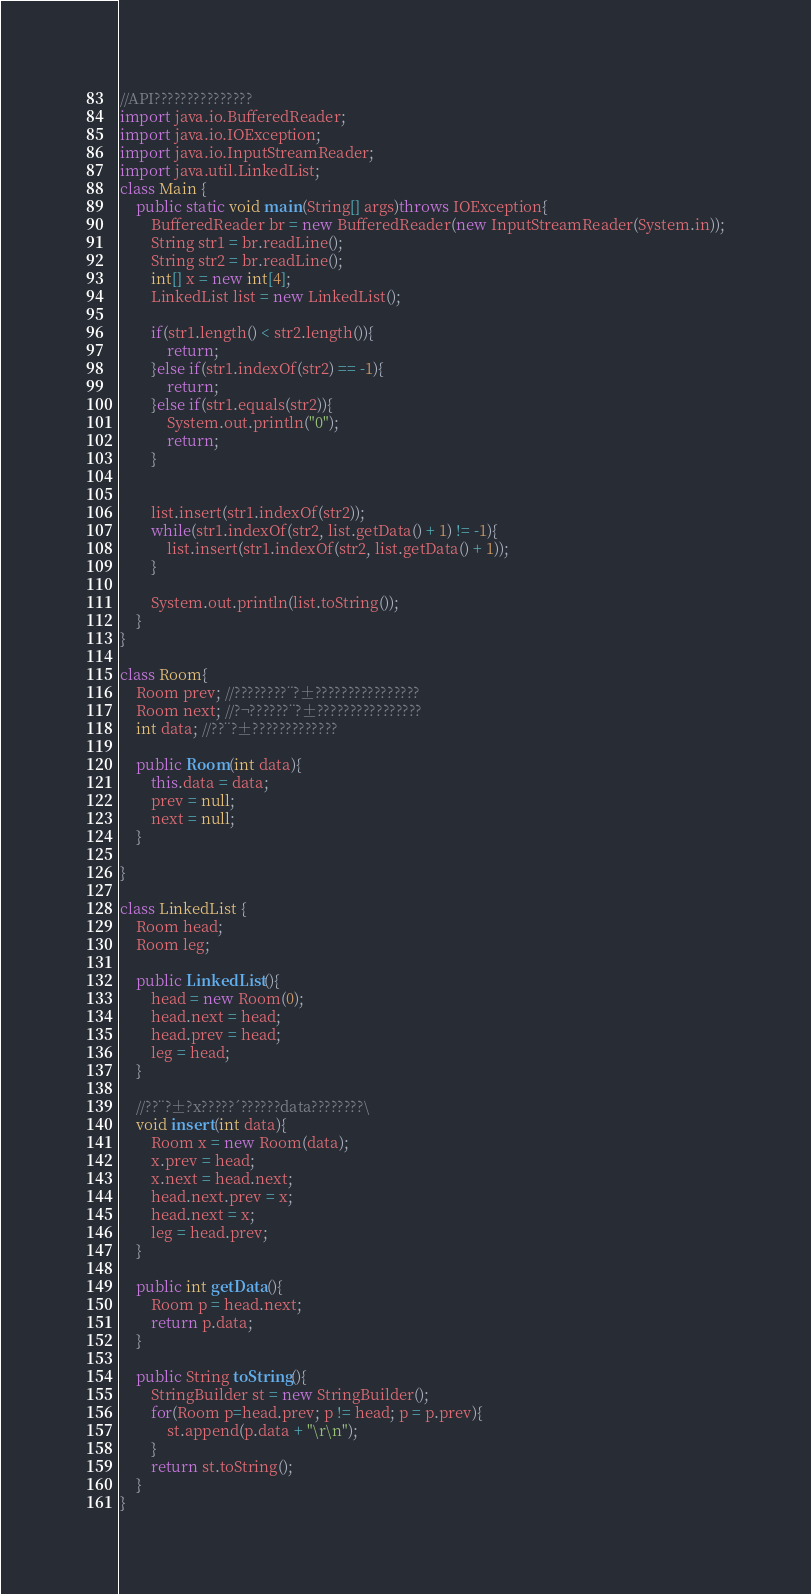<code> <loc_0><loc_0><loc_500><loc_500><_Java_>//API???????????????
import java.io.BufferedReader;
import java.io.IOException;
import java.io.InputStreamReader;
import java.util.LinkedList;
class Main {
  	public static void main(String[] args)throws IOException{
		BufferedReader br = new BufferedReader(new InputStreamReader(System.in));
		String str1 = br.readLine();
		String str2 = br.readLine();
		int[] x = new int[4];
		LinkedList list = new LinkedList();
		
		if(str1.length() < str2.length()){
			return;
		}else if(str1.indexOf(str2) == -1){
			return;
		}else if(str1.equals(str2)){
			System.out.println("0");
			return;
		}
		
		
		list.insert(str1.indexOf(str2));
		while(str1.indexOf(str2, list.getData() + 1) != -1){
			list.insert(str1.indexOf(str2, list.getData() + 1));
		}
		
		System.out.println(list.toString());
	}
}

class Room{
	Room prev; //????????¨?±????????????????
	Room next; //?¬??????¨?±????????????????
	int data; //??¨?±?????????????
	
	public Room(int data){
		this.data = data;
		prev = null;
		next = null;
	}

}

class LinkedList {
	Room head;
	Room leg;
	
	public LinkedList(){
		head = new Room(0);
		head.next = head;
		head.prev = head;
		leg = head;
	}
	
	//??¨?±?x?????´??????data????????\
	void insert(int data){
		Room x = new Room(data);
		x.prev = head;
		x.next = head.next;
		head.next.prev = x;
		head.next = x;
		leg = head.prev;
	}
	
	public int getData(){
		Room p = head.next;
		return p.data;
	}

	public String toString(){
		StringBuilder st = new StringBuilder();
		for(Room p=head.prev; p != head; p = p.prev){
			st.append(p.data + "\r\n");
		}
		return st.toString();
	}
} </code> 